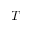<formula> <loc_0><loc_0><loc_500><loc_500>T _ { - }</formula> 